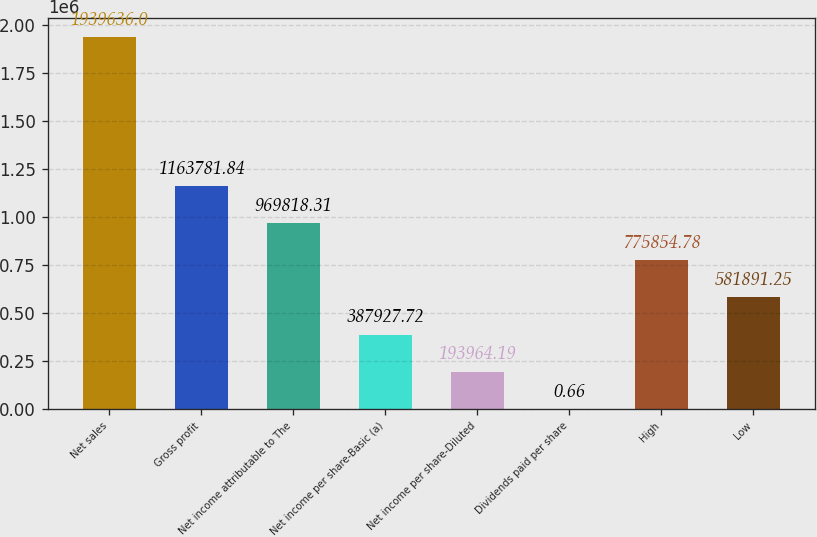<chart> <loc_0><loc_0><loc_500><loc_500><bar_chart><fcel>Net sales<fcel>Gross profit<fcel>Net income attributable to The<fcel>Net income per share-Basic (a)<fcel>Net income per share-Diluted<fcel>Dividends paid per share<fcel>High<fcel>Low<nl><fcel>1.93964e+06<fcel>1.16378e+06<fcel>969818<fcel>387928<fcel>193964<fcel>0.66<fcel>775855<fcel>581891<nl></chart> 